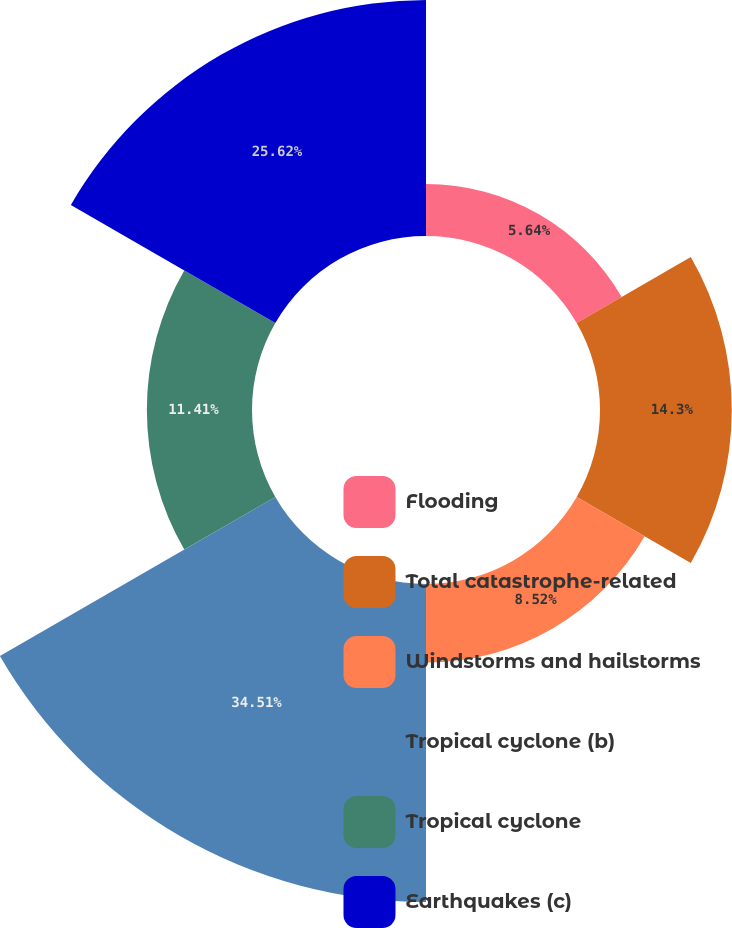<chart> <loc_0><loc_0><loc_500><loc_500><pie_chart><fcel>Flooding<fcel>Total catastrophe-related<fcel>Windstorms and hailstorms<fcel>Tropical cyclone (b)<fcel>Tropical cyclone<fcel>Earthquakes (c)<nl><fcel>5.64%<fcel>14.3%<fcel>8.52%<fcel>34.51%<fcel>11.41%<fcel>25.62%<nl></chart> 